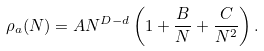<formula> <loc_0><loc_0><loc_500><loc_500>\rho _ { a } ( N ) = A N ^ { D - d } \left ( 1 + \frac { B } { N } + \frac { C } { N ^ { 2 } } \right ) .</formula> 